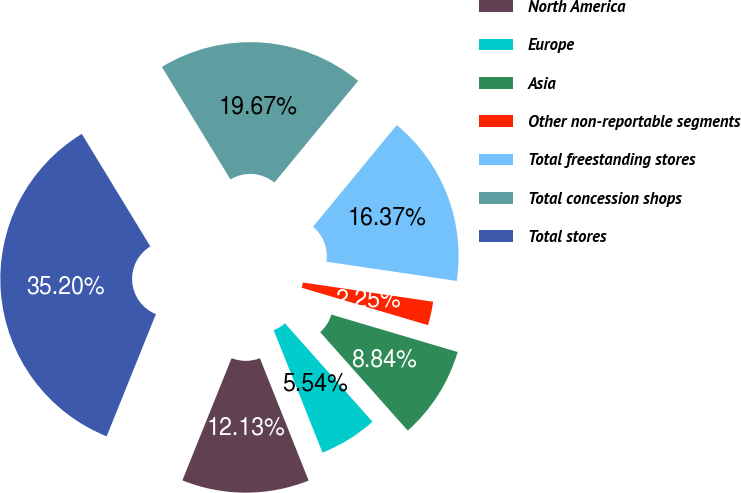<chart> <loc_0><loc_0><loc_500><loc_500><pie_chart><fcel>North America<fcel>Europe<fcel>Asia<fcel>Other non-reportable segments<fcel>Total freestanding stores<fcel>Total concession shops<fcel>Total stores<nl><fcel>12.13%<fcel>5.54%<fcel>8.84%<fcel>2.25%<fcel>16.37%<fcel>19.67%<fcel>35.2%<nl></chart> 